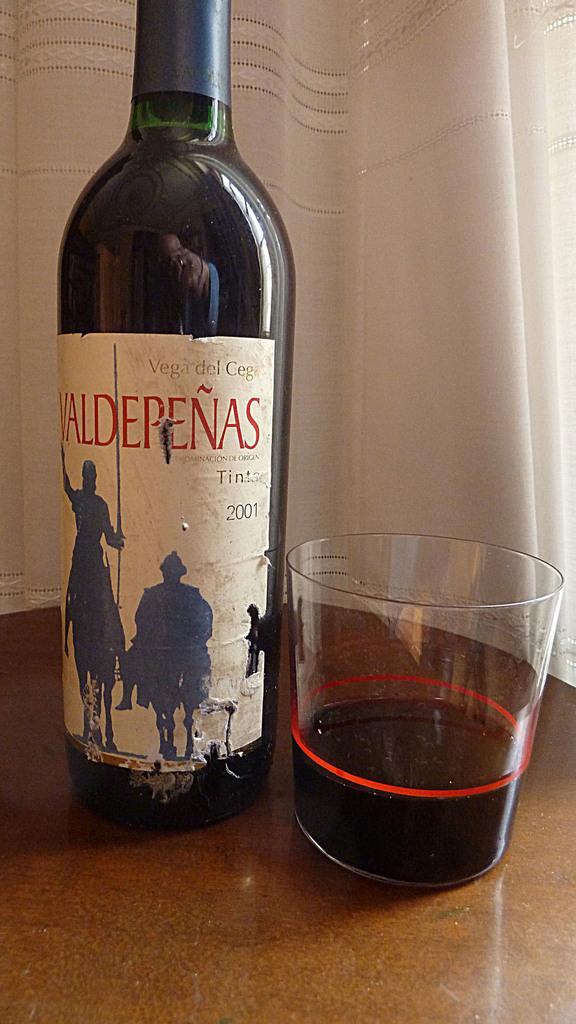Provide a one-sentence caption for the provided image. A wine bottle from 2001 is next to a glass with wine in it. 